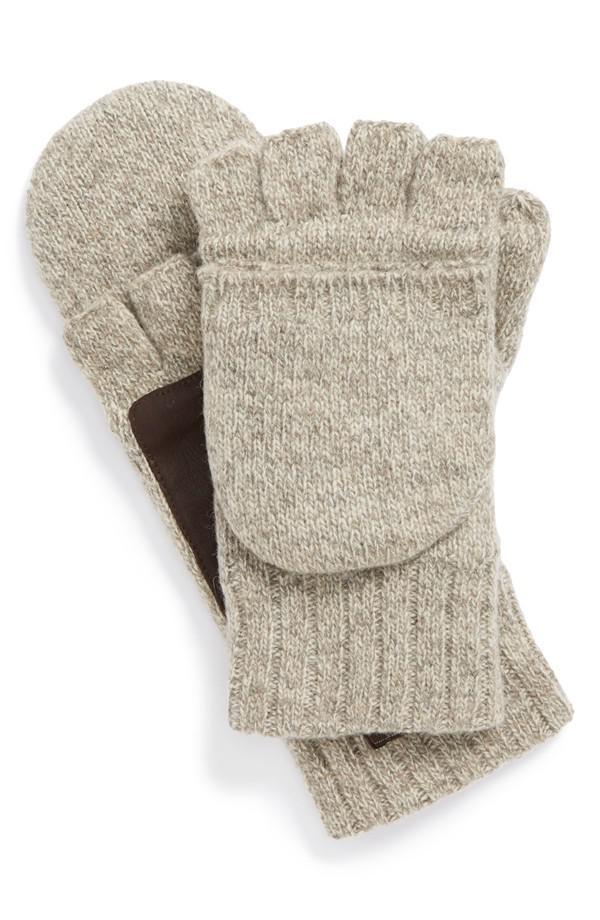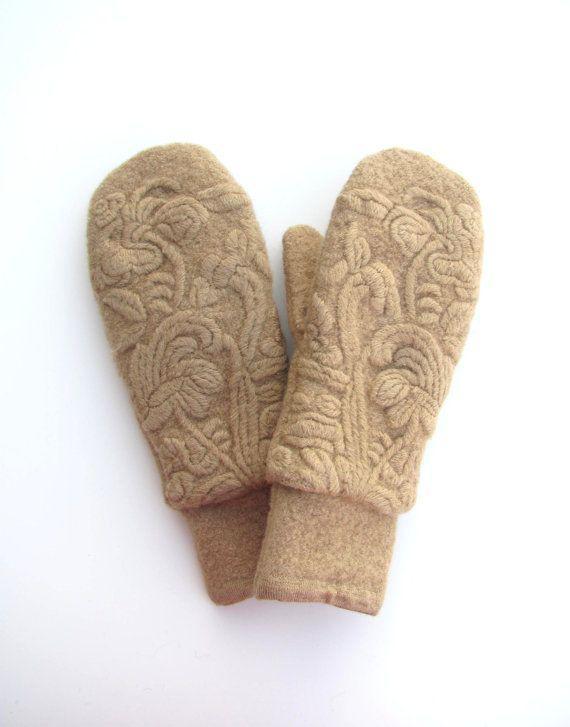The first image is the image on the left, the second image is the image on the right. Examine the images to the left and right. Is the description "A closed round mitten is faced palms down with the thumb part on the left side." accurate? Answer yes or no. Yes. The first image is the image on the left, the second image is the image on the right. For the images displayed, is the sentence "One pair of mittens is solid camel colored, and the other is heather colored with a dark brown patch." factually correct? Answer yes or no. Yes. 